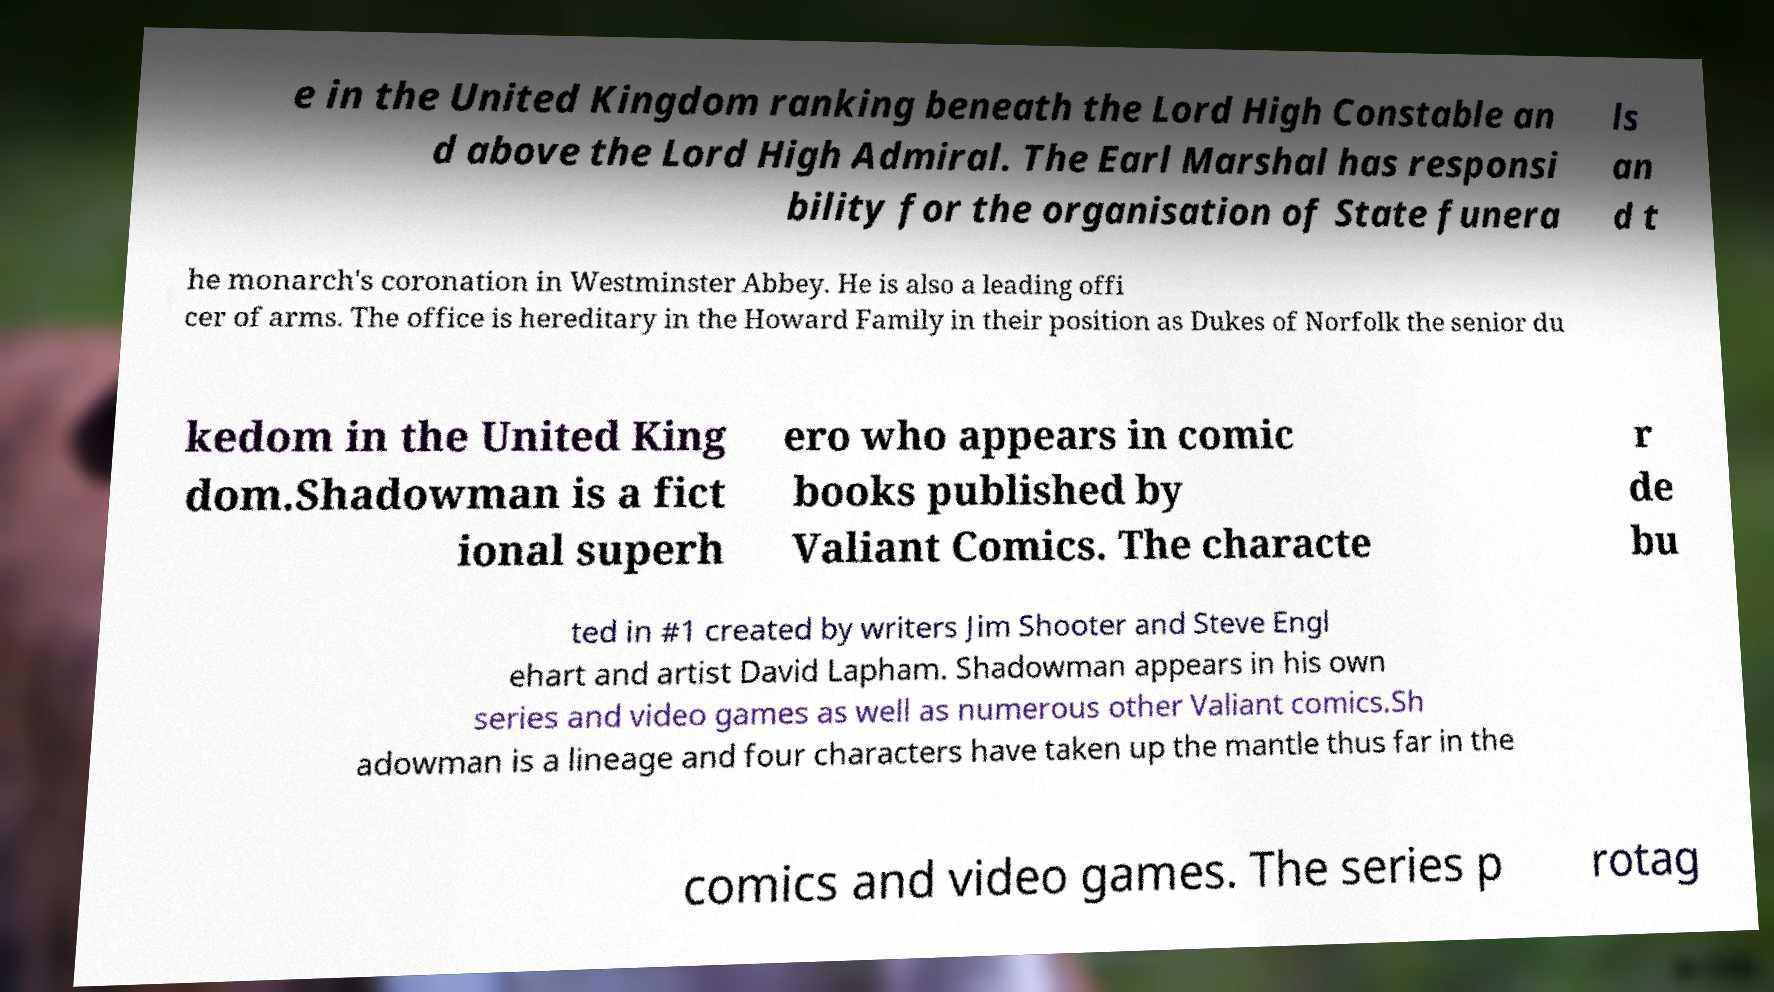For documentation purposes, I need the text within this image transcribed. Could you provide that? e in the United Kingdom ranking beneath the Lord High Constable an d above the Lord High Admiral. The Earl Marshal has responsi bility for the organisation of State funera ls an d t he monarch's coronation in Westminster Abbey. He is also a leading offi cer of arms. The office is hereditary in the Howard Family in their position as Dukes of Norfolk the senior du kedom in the United King dom.Shadowman is a fict ional superh ero who appears in comic books published by Valiant Comics. The characte r de bu ted in #1 created by writers Jim Shooter and Steve Engl ehart and artist David Lapham. Shadowman appears in his own series and video games as well as numerous other Valiant comics.Sh adowman is a lineage and four characters have taken up the mantle thus far in the comics and video games. The series p rotag 